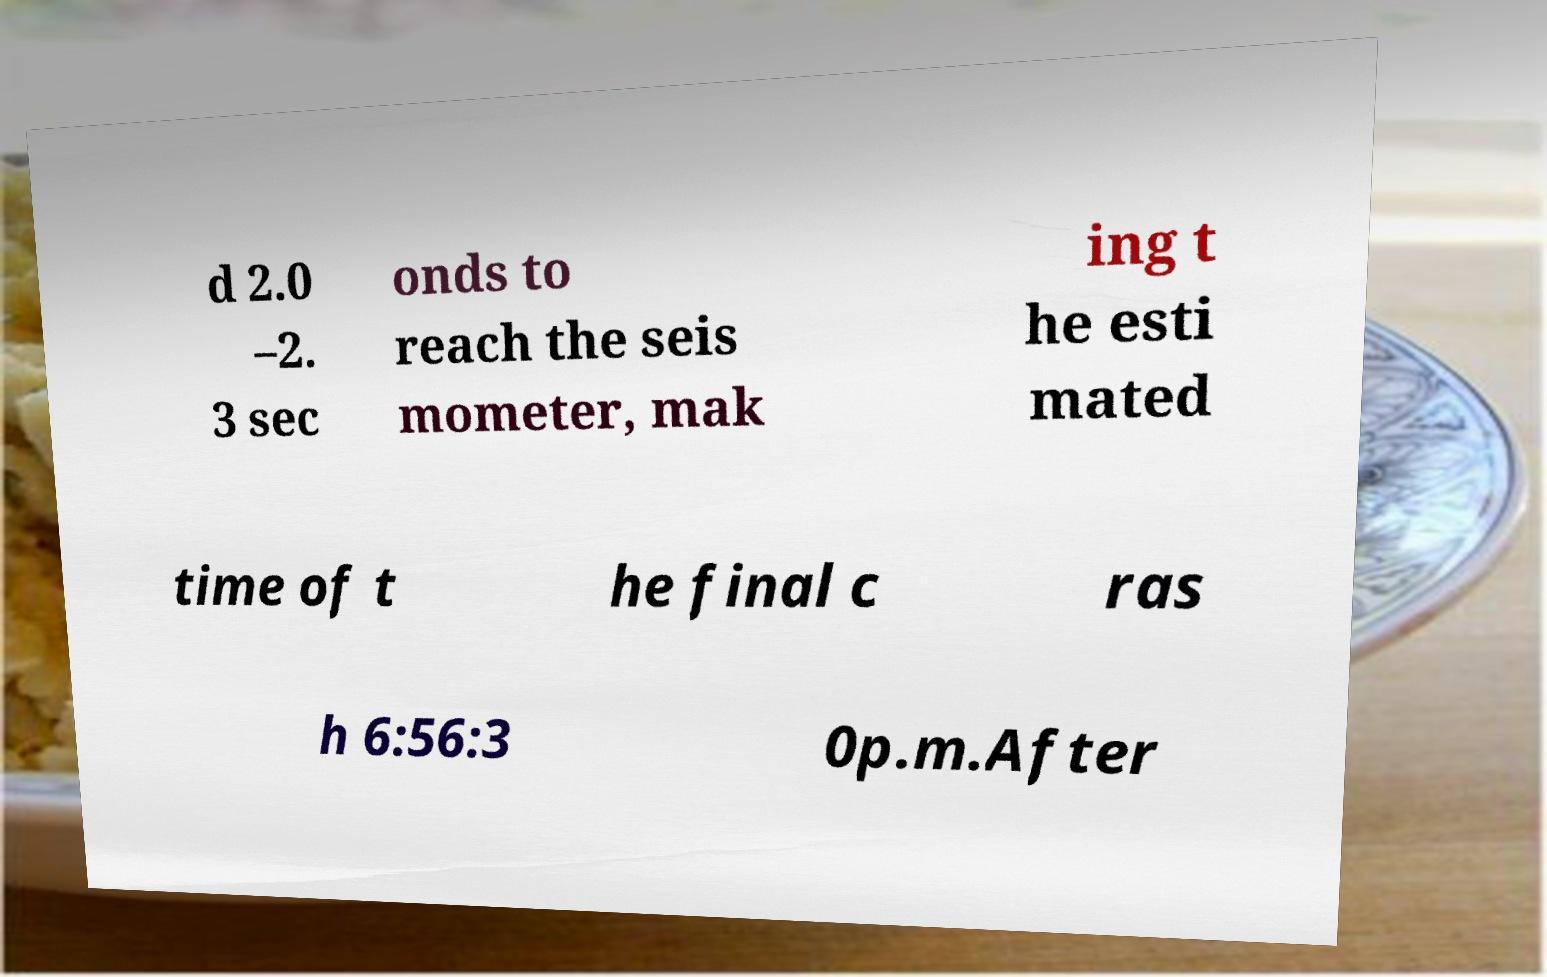Can you read and provide the text displayed in the image?This photo seems to have some interesting text. Can you extract and type it out for me? d 2.0 –2. 3 sec onds to reach the seis mometer, mak ing t he esti mated time of t he final c ras h 6:56:3 0p.m.After 